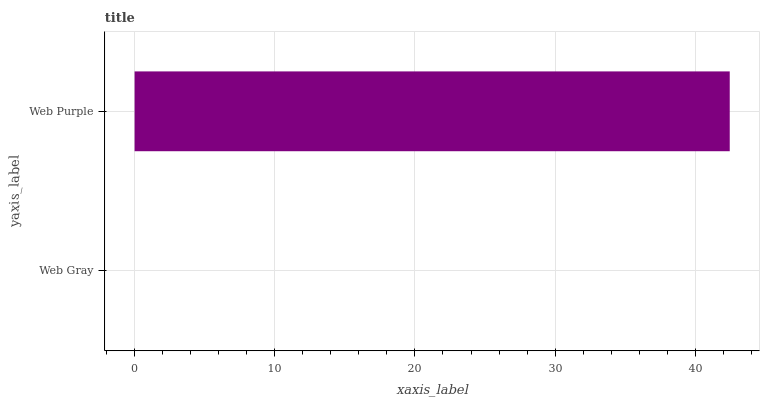Is Web Gray the minimum?
Answer yes or no. Yes. Is Web Purple the maximum?
Answer yes or no. Yes. Is Web Purple the minimum?
Answer yes or no. No. Is Web Purple greater than Web Gray?
Answer yes or no. Yes. Is Web Gray less than Web Purple?
Answer yes or no. Yes. Is Web Gray greater than Web Purple?
Answer yes or no. No. Is Web Purple less than Web Gray?
Answer yes or no. No. Is Web Purple the high median?
Answer yes or no. Yes. Is Web Gray the low median?
Answer yes or no. Yes. Is Web Gray the high median?
Answer yes or no. No. Is Web Purple the low median?
Answer yes or no. No. 